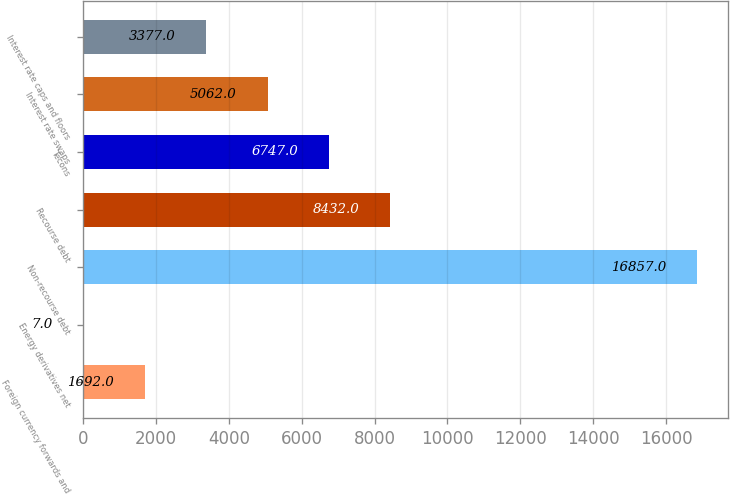Convert chart. <chart><loc_0><loc_0><loc_500><loc_500><bar_chart><fcel>Foreign currency forwards and<fcel>Energy derivatives net<fcel>Non-recourse debt<fcel>Recourse debt<fcel>Tecons<fcel>Interest rate swaps<fcel>Interest rate caps and floors<nl><fcel>1692<fcel>7<fcel>16857<fcel>8432<fcel>6747<fcel>5062<fcel>3377<nl></chart> 